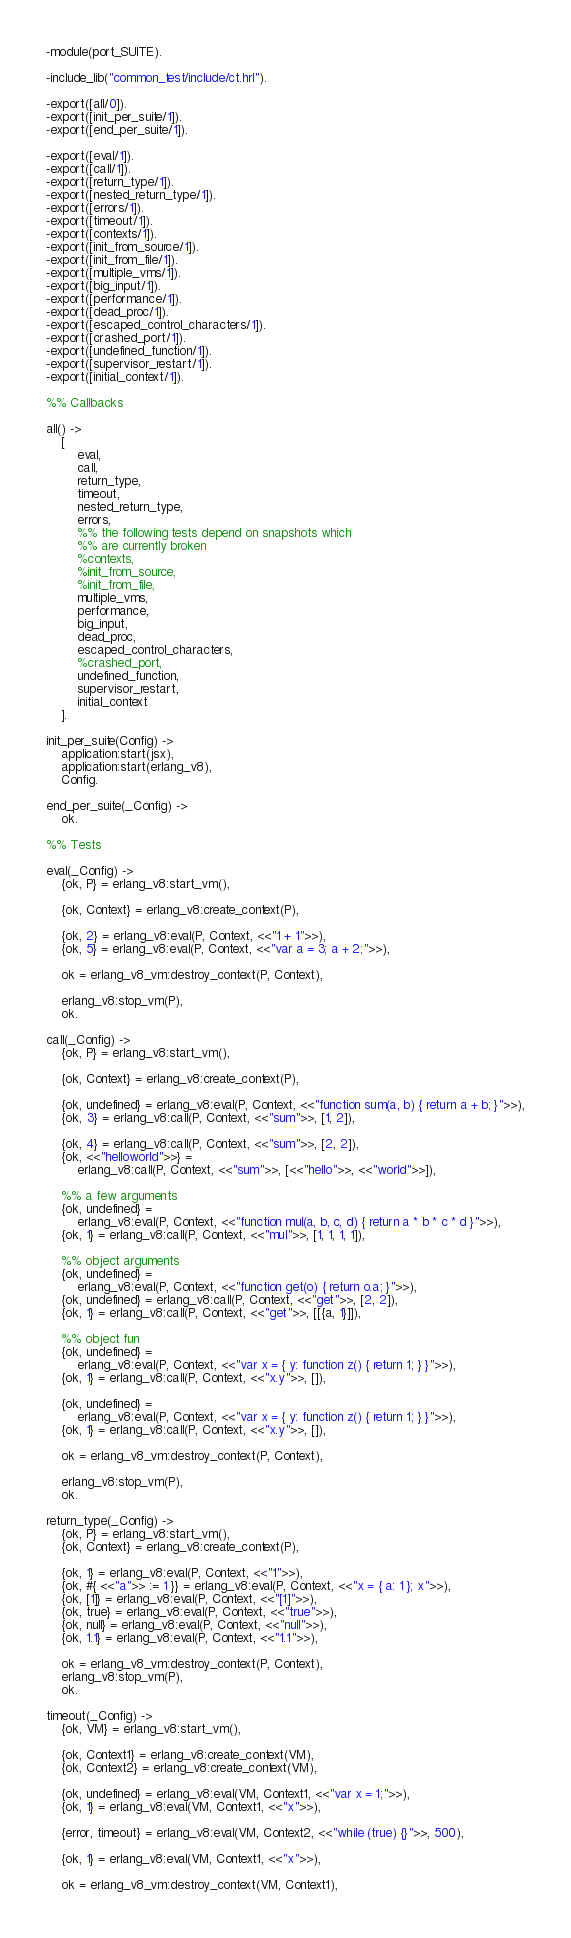Convert code to text. <code><loc_0><loc_0><loc_500><loc_500><_Erlang_>-module(port_SUITE).

-include_lib("common_test/include/ct.hrl").

-export([all/0]).
-export([init_per_suite/1]).
-export([end_per_suite/1]).

-export([eval/1]).
-export([call/1]).
-export([return_type/1]).
-export([nested_return_type/1]).
-export([errors/1]).
-export([timeout/1]).
-export([contexts/1]).
-export([init_from_source/1]).
-export([init_from_file/1]).
-export([multiple_vms/1]).
-export([big_input/1]).
-export([performance/1]).
-export([dead_proc/1]).
-export([escaped_control_characters/1]).
-export([crashed_port/1]).
-export([undefined_function/1]).
-export([supervisor_restart/1]).
-export([initial_context/1]).

%% Callbacks

all() ->
    [
        eval,
        call,
        return_type,
        timeout,
        nested_return_type,
        errors,
        %% the following tests depend on snapshots which
        %% are currently broken
        %contexts,
        %init_from_source,
        %init_from_file,
        multiple_vms,
        performance,
        big_input,
        dead_proc,
        escaped_control_characters,
        %crashed_port,
        undefined_function,
        supervisor_restart,
        initial_context
    ].

init_per_suite(Config) ->
    application:start(jsx),
    application:start(erlang_v8),
    Config.

end_per_suite(_Config) ->
    ok.

%% Tests

eval(_Config) ->
    {ok, P} = erlang_v8:start_vm(),

    {ok, Context} = erlang_v8:create_context(P),

    {ok, 2} = erlang_v8:eval(P, Context, <<"1 + 1">>),
    {ok, 5} = erlang_v8:eval(P, Context, <<"var a = 3; a + 2;">>),

    ok = erlang_v8_vm:destroy_context(P, Context),

    erlang_v8:stop_vm(P),
    ok.

call(_Config) ->
    {ok, P} = erlang_v8:start_vm(),

    {ok, Context} = erlang_v8:create_context(P),
    
    {ok, undefined} = erlang_v8:eval(P, Context, <<"function sum(a, b) { return a + b; }">>),
    {ok, 3} = erlang_v8:call(P, Context, <<"sum">>, [1, 2]),

    {ok, 4} = erlang_v8:call(P, Context, <<"sum">>, [2, 2]),
    {ok, <<"helloworld">>} =
        erlang_v8:call(P, Context, <<"sum">>, [<<"hello">>, <<"world">>]),

    %% a few arguments
    {ok, undefined} =
        erlang_v8:eval(P, Context, <<"function mul(a, b, c, d) { return a * b * c * d }">>),
    {ok, 1} = erlang_v8:call(P, Context, <<"mul">>, [1, 1, 1, 1]),

    %% object arguments
    {ok, undefined} =
        erlang_v8:eval(P, Context, <<"function get(o) { return o.a; }">>),
    {ok, undefined} = erlang_v8:call(P, Context, <<"get">>, [2, 2]),
    {ok, 1} = erlang_v8:call(P, Context, <<"get">>, [[{a, 1}]]),

    %% object fun
    {ok, undefined} =
        erlang_v8:eval(P, Context, <<"var x = { y: function z() { return 1; } }">>),
    {ok, 1} = erlang_v8:call(P, Context, <<"x.y">>, []),

    {ok, undefined} =
        erlang_v8:eval(P, Context, <<"var x = { y: function z() { return 1; } }">>),
    {ok, 1} = erlang_v8:call(P, Context, <<"x.y">>, []),

    ok = erlang_v8_vm:destroy_context(P, Context),

    erlang_v8:stop_vm(P),
    ok.

return_type(_Config) ->
    {ok, P} = erlang_v8:start_vm(),
    {ok, Context} = erlang_v8:create_context(P),

    {ok, 1} = erlang_v8:eval(P, Context, <<"1">>),
    {ok, #{ <<"a">> := 1 }} = erlang_v8:eval(P, Context, <<"x = { a: 1 }; x">>),
    {ok, [1]} = erlang_v8:eval(P, Context, <<"[1]">>),
    {ok, true} = erlang_v8:eval(P, Context, <<"true">>),
    {ok, null} = erlang_v8:eval(P, Context, <<"null">>),
    {ok, 1.1} = erlang_v8:eval(P, Context, <<"1.1">>),

    ok = erlang_v8_vm:destroy_context(P, Context),
    erlang_v8:stop_vm(P),
    ok.

timeout(_Config) ->
    {ok, VM} = erlang_v8:start_vm(),

    {ok, Context1} = erlang_v8:create_context(VM),
    {ok, Context2} = erlang_v8:create_context(VM),

    {ok, undefined} = erlang_v8:eval(VM, Context1, <<"var x = 1;">>),
    {ok, 1} = erlang_v8:eval(VM, Context1, <<"x">>),

    {error, timeout} = erlang_v8:eval(VM, Context2, <<"while (true) {}">>, 500),

    {ok, 1} = erlang_v8:eval(VM, Context1, <<"x">>),

    ok = erlang_v8_vm:destroy_context(VM, Context1),</code> 